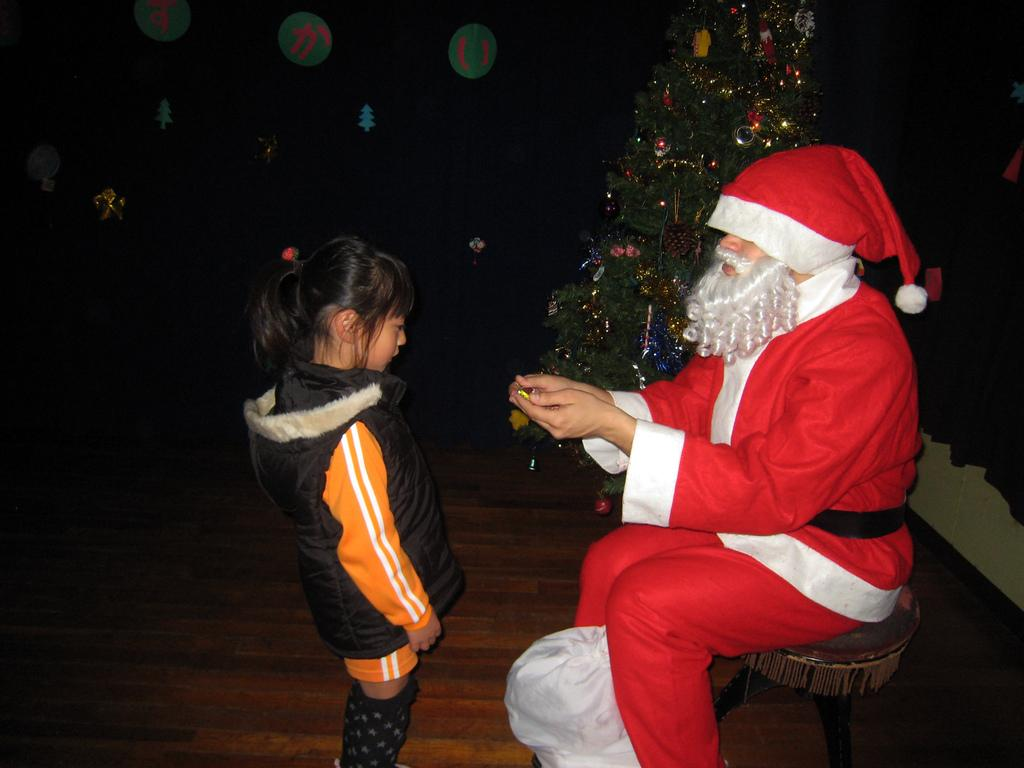Who is the main subject in the picture? There is a Santa Claus in the picture. What is Santa Claus doing in the picture? Santa Claus is sitting on a chair. What is Santa Claus holding in the picture? Santa Claus is holding candies. What can be seen in the background of the picture? There is a Christmas tree in the background. Who is present in front of Santa Claus? There is a girl standing in front of Santa Claus. How many goats are present in the picture? There are no goats present in the picture. What type of peace is depicted in the image? The image does not depict any specific type of peace; it features Santa Claus, a girl, and a Christmas tree. 